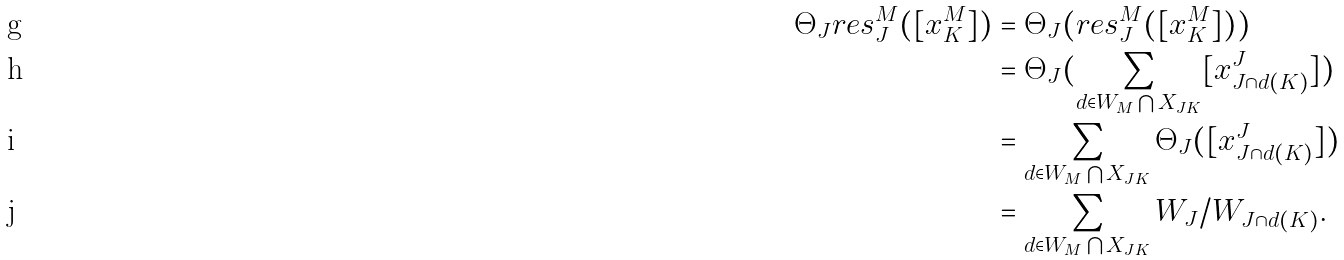Convert formula to latex. <formula><loc_0><loc_0><loc_500><loc_500>{ \Theta _ { J } } { r e s _ { J } ^ { M } } ( [ x _ { K } ^ { M } ] ) & = { \Theta _ { J } } ( { r e s _ { J } ^ { M } } ( [ x _ { K } ^ { M } ] ) ) \\ & = { \Theta _ { J } } ( \sum _ { d \in { { W _ { M } } \bigcap { X _ { J K } } } } [ { x _ { J \cap { d ( K ) } } ^ { J } } ] ) \\ & = \sum _ { d \in { { W _ { M } } \bigcap { X _ { J K } } } } { \Theta _ { J } } ( [ { x _ { J \cap { d ( K ) } } ^ { J } } ] ) \\ & = \sum _ { d \in { { W _ { M } } \bigcap { X _ { J K } } } } { W _ { J } / W _ { J \cap { d ( K ) } } } .</formula> 